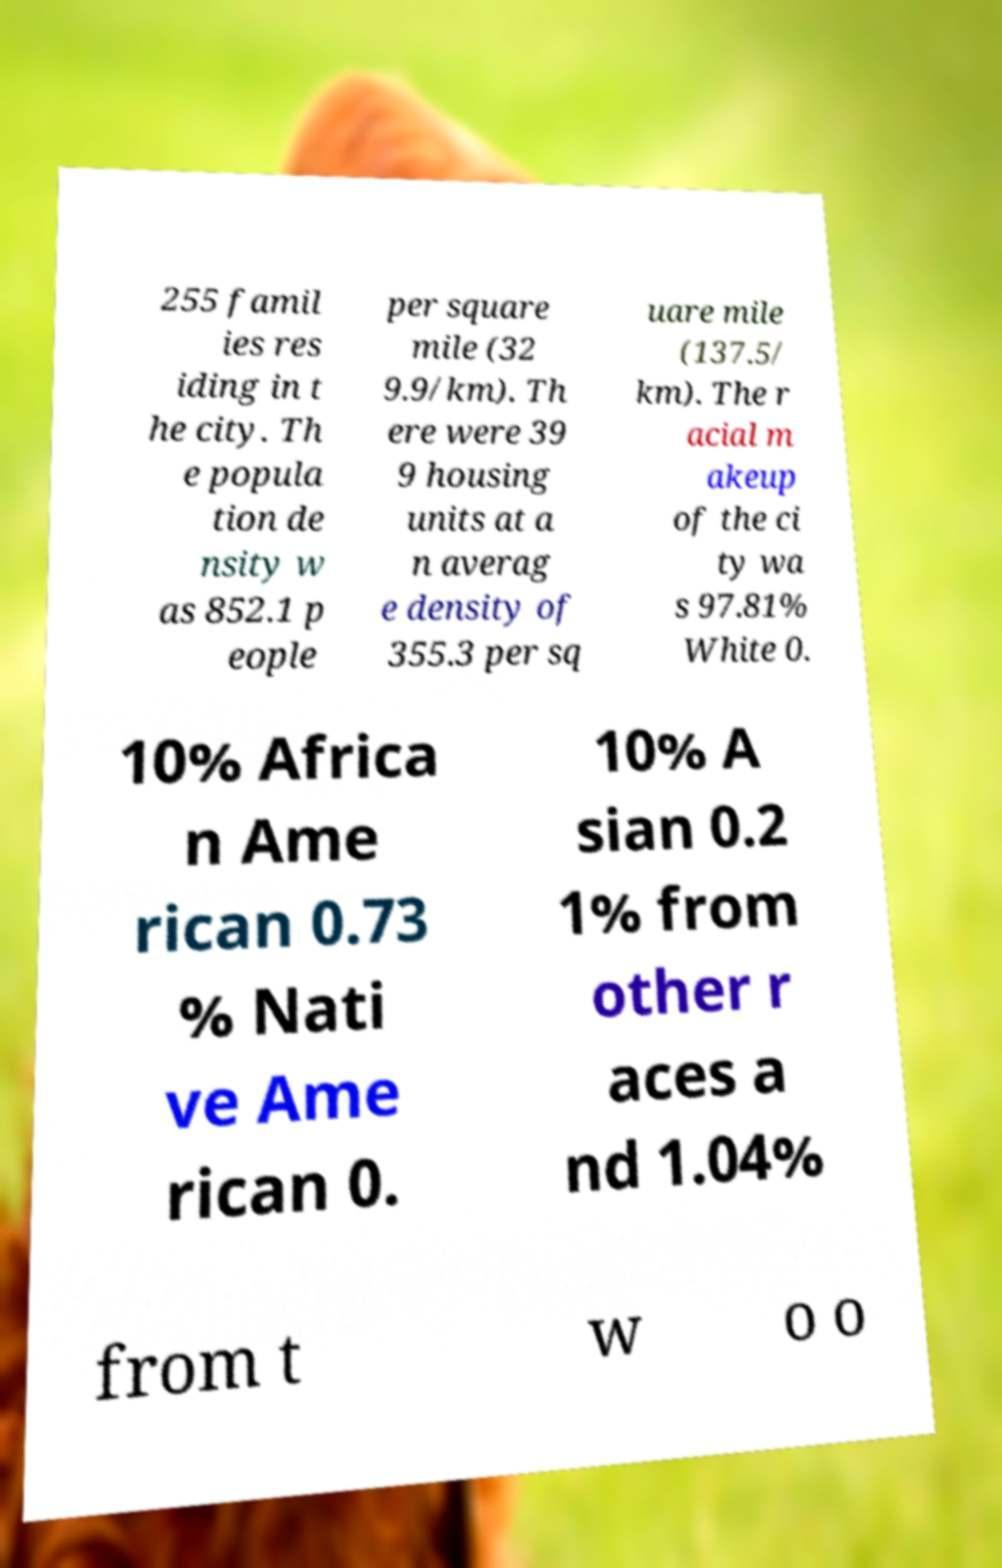Please identify and transcribe the text found in this image. 255 famil ies res iding in t he city. Th e popula tion de nsity w as 852.1 p eople per square mile (32 9.9/km). Th ere were 39 9 housing units at a n averag e density of 355.3 per sq uare mile (137.5/ km). The r acial m akeup of the ci ty wa s 97.81% White 0. 10% Africa n Ame rican 0.73 % Nati ve Ame rican 0. 10% A sian 0.2 1% from other r aces a nd 1.04% from t w o o 